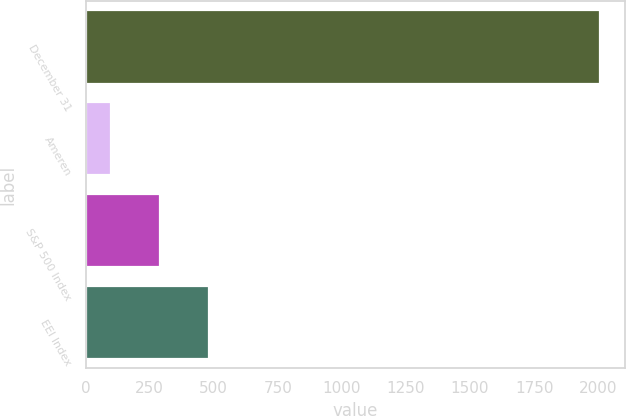Convert chart. <chart><loc_0><loc_0><loc_500><loc_500><bar_chart><fcel>December 31<fcel>Ameren<fcel>S&P 500 Index<fcel>EEI Index<nl><fcel>2006<fcel>100<fcel>290.6<fcel>481.2<nl></chart> 